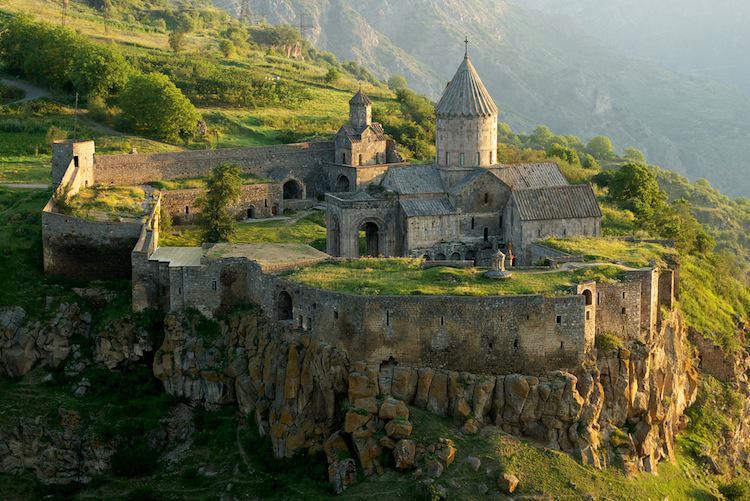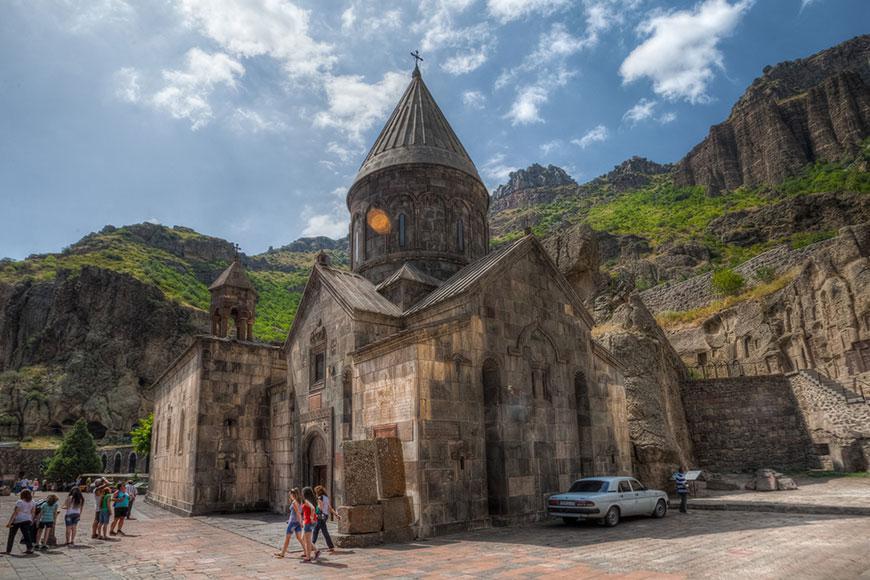The first image is the image on the left, the second image is the image on the right. For the images displayed, is the sentence "There is a cross atop the building in one of the images." factually correct? Answer yes or no. Yes. 